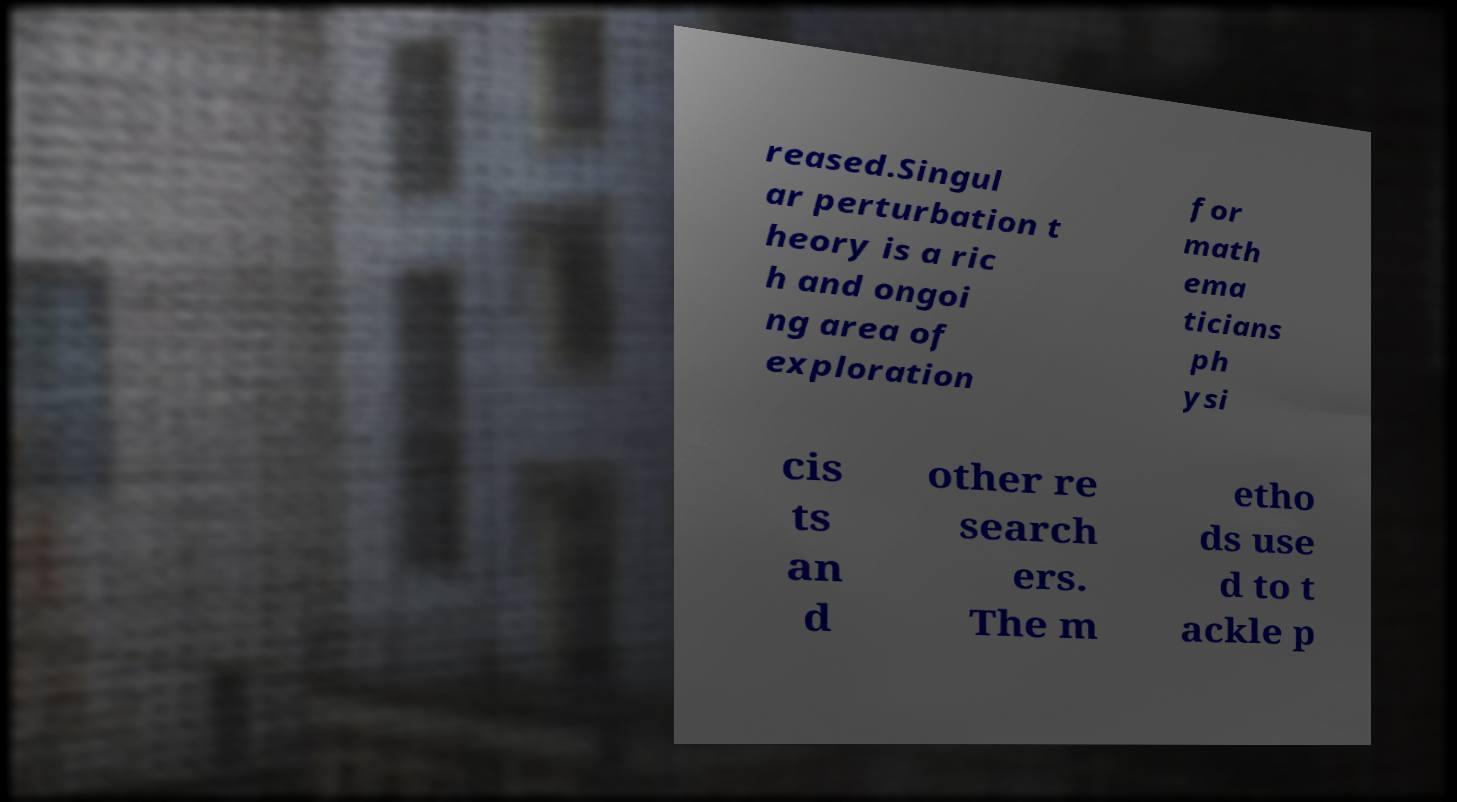Please read and relay the text visible in this image. What does it say? reased.Singul ar perturbation t heory is a ric h and ongoi ng area of exploration for math ema ticians ph ysi cis ts an d other re search ers. The m etho ds use d to t ackle p 